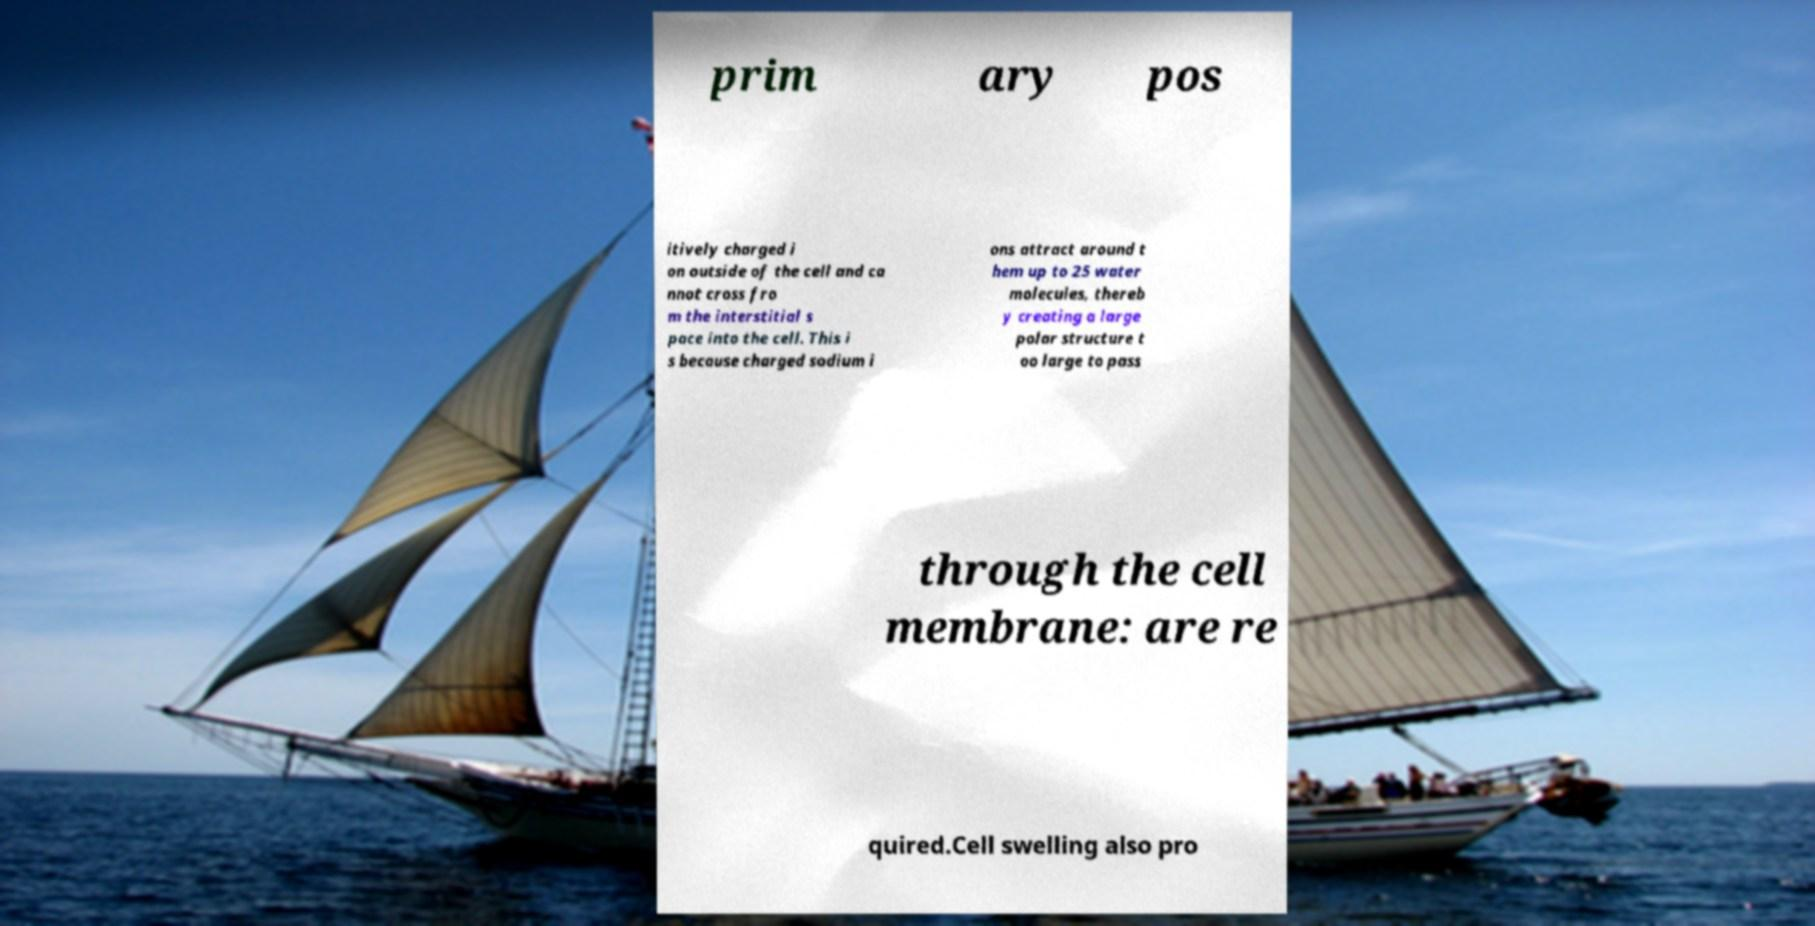Please identify and transcribe the text found in this image. prim ary pos itively charged i on outside of the cell and ca nnot cross fro m the interstitial s pace into the cell. This i s because charged sodium i ons attract around t hem up to 25 water molecules, thereb y creating a large polar structure t oo large to pass through the cell membrane: are re quired.Cell swelling also pro 